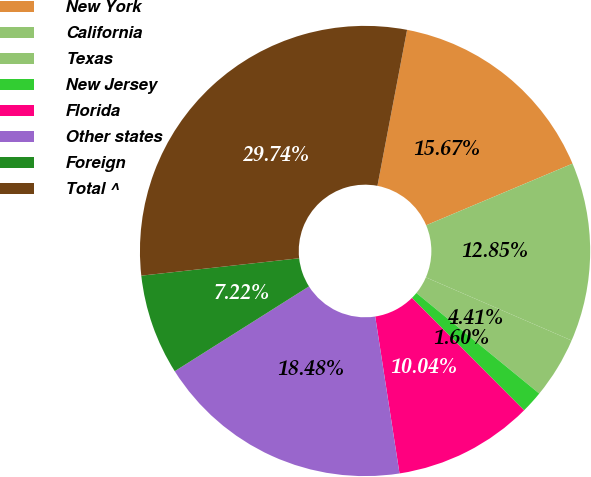<chart> <loc_0><loc_0><loc_500><loc_500><pie_chart><fcel>New York<fcel>California<fcel>Texas<fcel>New Jersey<fcel>Florida<fcel>Other states<fcel>Foreign<fcel>Total ^<nl><fcel>15.67%<fcel>12.85%<fcel>4.41%<fcel>1.6%<fcel>10.04%<fcel>18.48%<fcel>7.22%<fcel>29.74%<nl></chart> 